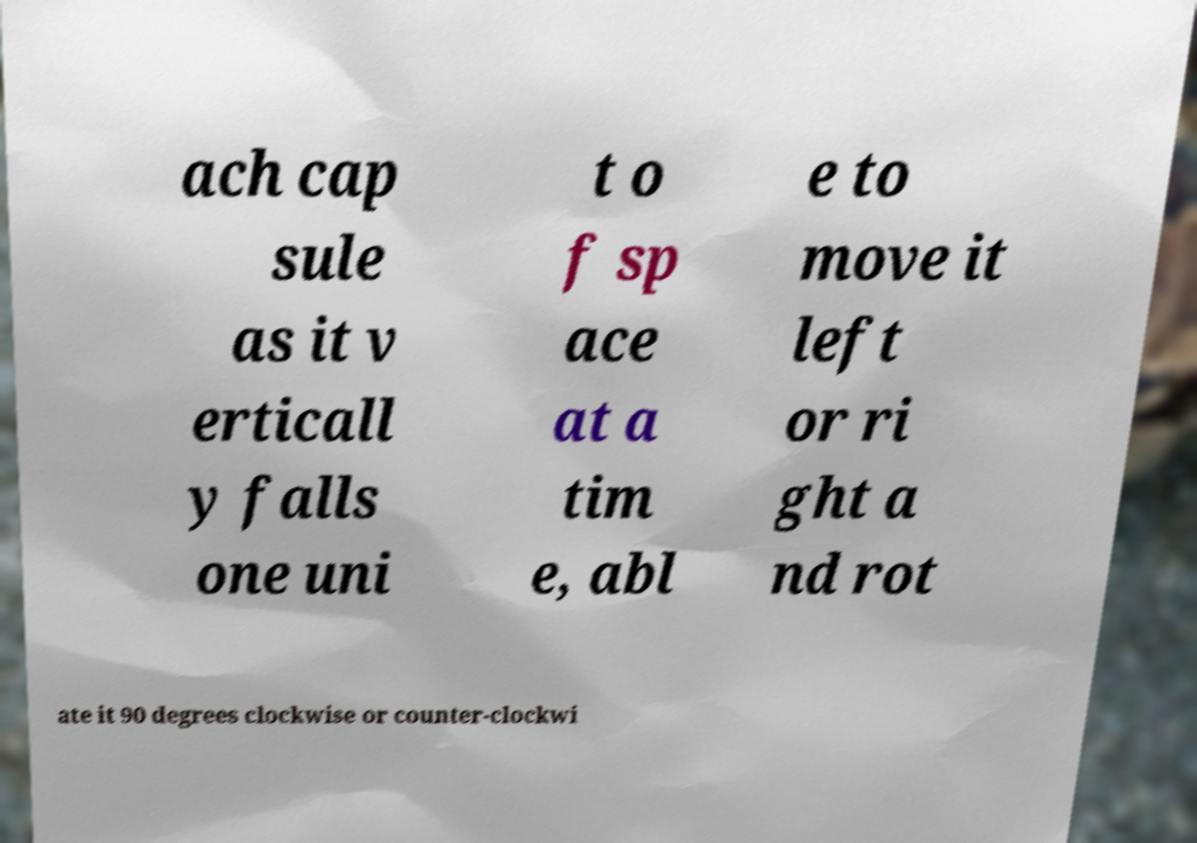What messages or text are displayed in this image? I need them in a readable, typed format. ach cap sule as it v erticall y falls one uni t o f sp ace at a tim e, abl e to move it left or ri ght a nd rot ate it 90 degrees clockwise or counter-clockwi 